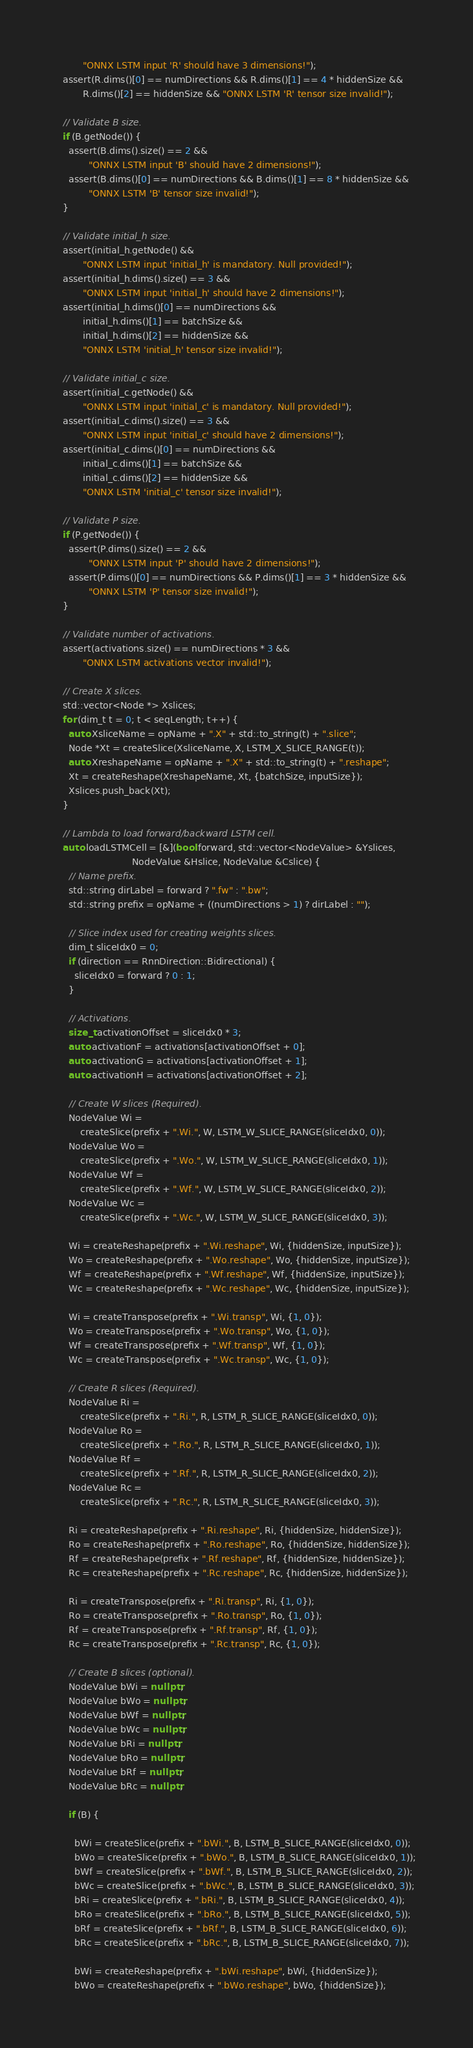<code> <loc_0><loc_0><loc_500><loc_500><_C++_>         "ONNX LSTM input 'R' should have 3 dimensions!");
  assert(R.dims()[0] == numDirections && R.dims()[1] == 4 * hiddenSize &&
         R.dims()[2] == hiddenSize && "ONNX LSTM 'R' tensor size invalid!");

  // Validate B size.
  if (B.getNode()) {
    assert(B.dims().size() == 2 &&
           "ONNX LSTM input 'B' should have 2 dimensions!");
    assert(B.dims()[0] == numDirections && B.dims()[1] == 8 * hiddenSize &&
           "ONNX LSTM 'B' tensor size invalid!");
  }

  // Validate initial_h size.
  assert(initial_h.getNode() &&
         "ONNX LSTM input 'initial_h' is mandatory. Null provided!");
  assert(initial_h.dims().size() == 3 &&
         "ONNX LSTM input 'initial_h' should have 2 dimensions!");
  assert(initial_h.dims()[0] == numDirections &&
         initial_h.dims()[1] == batchSize &&
         initial_h.dims()[2] == hiddenSize &&
         "ONNX LSTM 'initial_h' tensor size invalid!");

  // Validate initial_c size.
  assert(initial_c.getNode() &&
         "ONNX LSTM input 'initial_c' is mandatory. Null provided!");
  assert(initial_c.dims().size() == 3 &&
         "ONNX LSTM input 'initial_c' should have 2 dimensions!");
  assert(initial_c.dims()[0] == numDirections &&
         initial_c.dims()[1] == batchSize &&
         initial_c.dims()[2] == hiddenSize &&
         "ONNX LSTM 'initial_c' tensor size invalid!");

  // Validate P size.
  if (P.getNode()) {
    assert(P.dims().size() == 2 &&
           "ONNX LSTM input 'P' should have 2 dimensions!");
    assert(P.dims()[0] == numDirections && P.dims()[1] == 3 * hiddenSize &&
           "ONNX LSTM 'P' tensor size invalid!");
  }

  // Validate number of activations.
  assert(activations.size() == numDirections * 3 &&
         "ONNX LSTM activations vector invalid!");

  // Create X slices.
  std::vector<Node *> Xslices;
  for (dim_t t = 0; t < seqLength; t++) {
    auto XsliceName = opName + ".X" + std::to_string(t) + ".slice";
    Node *Xt = createSlice(XsliceName, X, LSTM_X_SLICE_RANGE(t));
    auto XreshapeName = opName + ".X" + std::to_string(t) + ".reshape";
    Xt = createReshape(XreshapeName, Xt, {batchSize, inputSize});
    Xslices.push_back(Xt);
  }

  // Lambda to load forward/backward LSTM cell.
  auto loadLSTMCell = [&](bool forward, std::vector<NodeValue> &Yslices,
                          NodeValue &Hslice, NodeValue &Cslice) {
    // Name prefix.
    std::string dirLabel = forward ? ".fw" : ".bw";
    std::string prefix = opName + ((numDirections > 1) ? dirLabel : "");

    // Slice index used for creating weights slices.
    dim_t sliceIdx0 = 0;
    if (direction == RnnDirection::Bidirectional) {
      sliceIdx0 = forward ? 0 : 1;
    }

    // Activations.
    size_t activationOffset = sliceIdx0 * 3;
    auto activationF = activations[activationOffset + 0];
    auto activationG = activations[activationOffset + 1];
    auto activationH = activations[activationOffset + 2];

    // Create W slices (Required).
    NodeValue Wi =
        createSlice(prefix + ".Wi.", W, LSTM_W_SLICE_RANGE(sliceIdx0, 0));
    NodeValue Wo =
        createSlice(prefix + ".Wo.", W, LSTM_W_SLICE_RANGE(sliceIdx0, 1));
    NodeValue Wf =
        createSlice(prefix + ".Wf.", W, LSTM_W_SLICE_RANGE(sliceIdx0, 2));
    NodeValue Wc =
        createSlice(prefix + ".Wc.", W, LSTM_W_SLICE_RANGE(sliceIdx0, 3));

    Wi = createReshape(prefix + ".Wi.reshape", Wi, {hiddenSize, inputSize});
    Wo = createReshape(prefix + ".Wo.reshape", Wo, {hiddenSize, inputSize});
    Wf = createReshape(prefix + ".Wf.reshape", Wf, {hiddenSize, inputSize});
    Wc = createReshape(prefix + ".Wc.reshape", Wc, {hiddenSize, inputSize});

    Wi = createTranspose(prefix + ".Wi.transp", Wi, {1, 0});
    Wo = createTranspose(prefix + ".Wo.transp", Wo, {1, 0});
    Wf = createTranspose(prefix + ".Wf.transp", Wf, {1, 0});
    Wc = createTranspose(prefix + ".Wc.transp", Wc, {1, 0});

    // Create R slices (Required).
    NodeValue Ri =
        createSlice(prefix + ".Ri.", R, LSTM_R_SLICE_RANGE(sliceIdx0, 0));
    NodeValue Ro =
        createSlice(prefix + ".Ro.", R, LSTM_R_SLICE_RANGE(sliceIdx0, 1));
    NodeValue Rf =
        createSlice(prefix + ".Rf.", R, LSTM_R_SLICE_RANGE(sliceIdx0, 2));
    NodeValue Rc =
        createSlice(prefix + ".Rc.", R, LSTM_R_SLICE_RANGE(sliceIdx0, 3));

    Ri = createReshape(prefix + ".Ri.reshape", Ri, {hiddenSize, hiddenSize});
    Ro = createReshape(prefix + ".Ro.reshape", Ro, {hiddenSize, hiddenSize});
    Rf = createReshape(prefix + ".Rf.reshape", Rf, {hiddenSize, hiddenSize});
    Rc = createReshape(prefix + ".Rc.reshape", Rc, {hiddenSize, hiddenSize});

    Ri = createTranspose(prefix + ".Ri.transp", Ri, {1, 0});
    Ro = createTranspose(prefix + ".Ro.transp", Ro, {1, 0});
    Rf = createTranspose(prefix + ".Rf.transp", Rf, {1, 0});
    Rc = createTranspose(prefix + ".Rc.transp", Rc, {1, 0});

    // Create B slices (optional).
    NodeValue bWi = nullptr;
    NodeValue bWo = nullptr;
    NodeValue bWf = nullptr;
    NodeValue bWc = nullptr;
    NodeValue bRi = nullptr;
    NodeValue bRo = nullptr;
    NodeValue bRf = nullptr;
    NodeValue bRc = nullptr;

    if (B) {

      bWi = createSlice(prefix + ".bWi.", B, LSTM_B_SLICE_RANGE(sliceIdx0, 0));
      bWo = createSlice(prefix + ".bWo.", B, LSTM_B_SLICE_RANGE(sliceIdx0, 1));
      bWf = createSlice(prefix + ".bWf.", B, LSTM_B_SLICE_RANGE(sliceIdx0, 2));
      bWc = createSlice(prefix + ".bWc.", B, LSTM_B_SLICE_RANGE(sliceIdx0, 3));
      bRi = createSlice(prefix + ".bRi.", B, LSTM_B_SLICE_RANGE(sliceIdx0, 4));
      bRo = createSlice(prefix + ".bRo.", B, LSTM_B_SLICE_RANGE(sliceIdx0, 5));
      bRf = createSlice(prefix + ".bRf.", B, LSTM_B_SLICE_RANGE(sliceIdx0, 6));
      bRc = createSlice(prefix + ".bRc.", B, LSTM_B_SLICE_RANGE(sliceIdx0, 7));

      bWi = createReshape(prefix + ".bWi.reshape", bWi, {hiddenSize});
      bWo = createReshape(prefix + ".bWo.reshape", bWo, {hiddenSize});</code> 